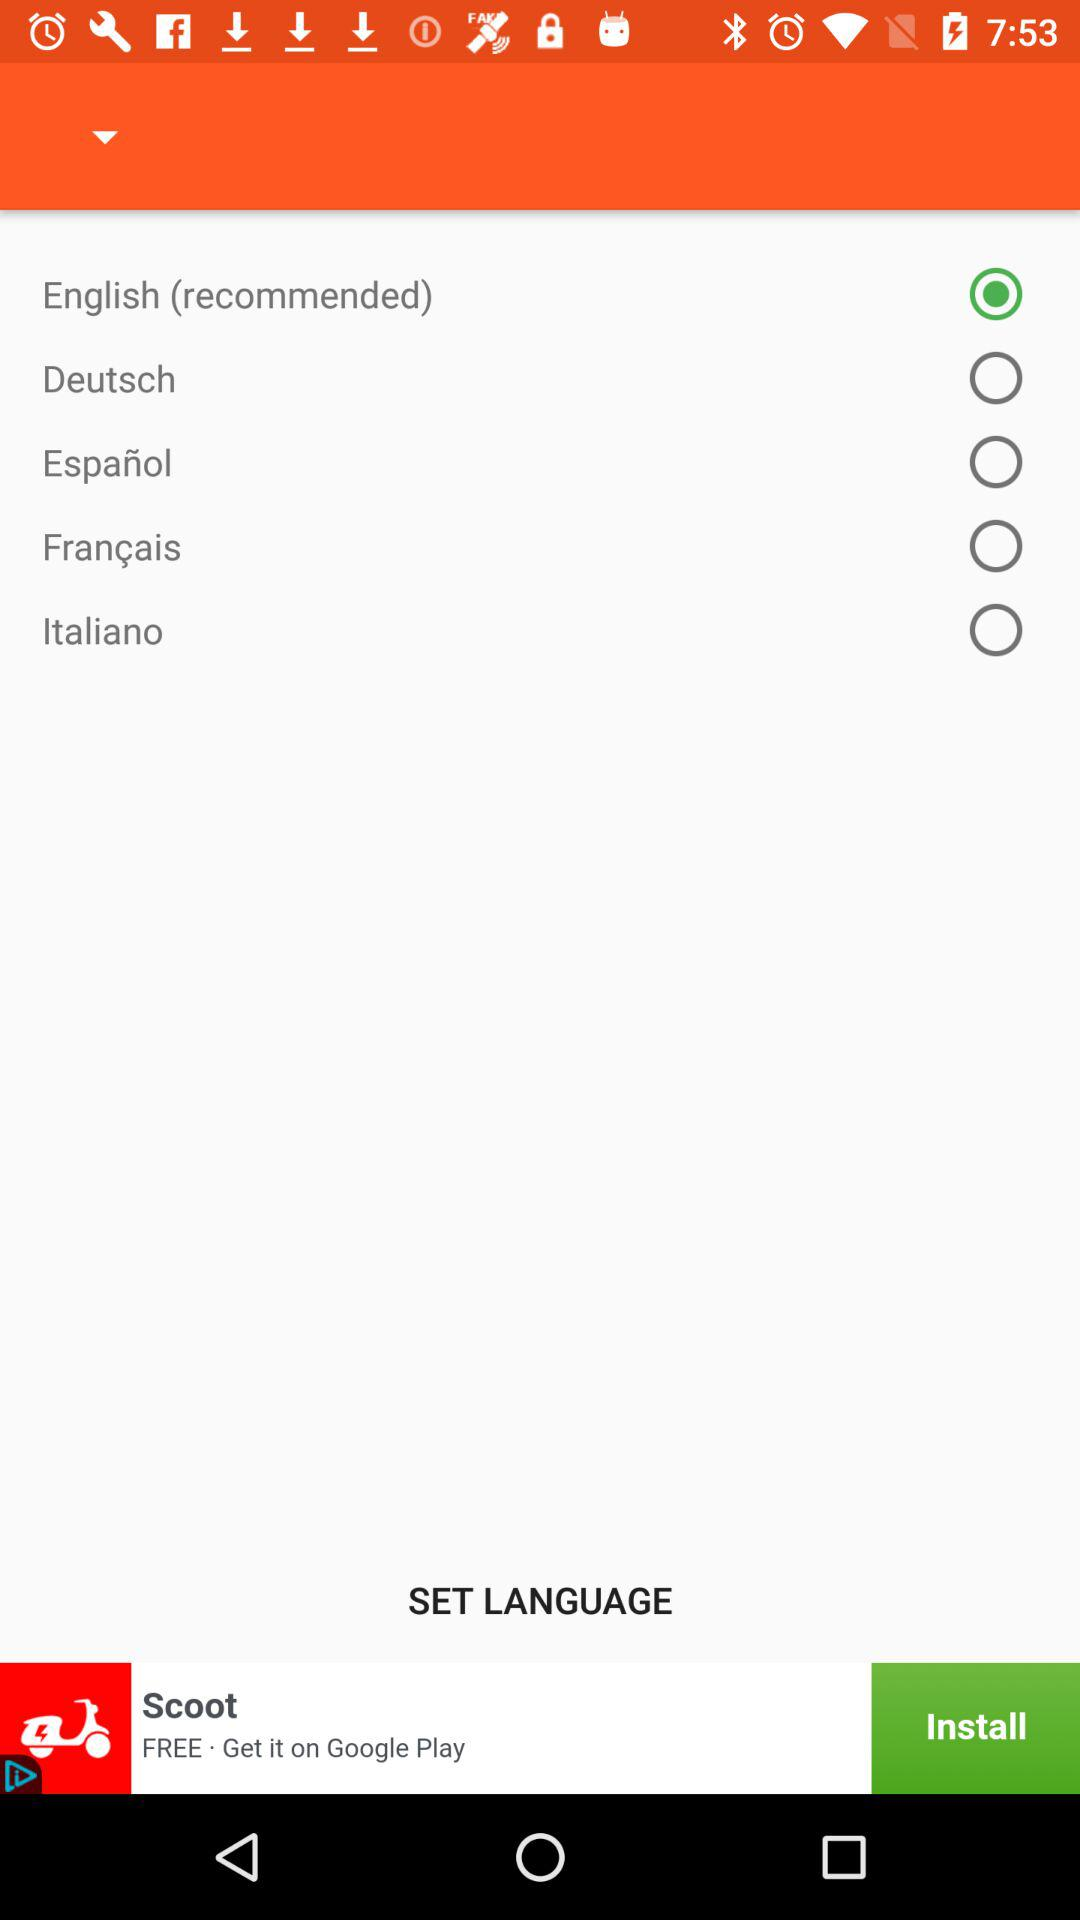How many languages are available for selection?
Answer the question using a single word or phrase. 5 